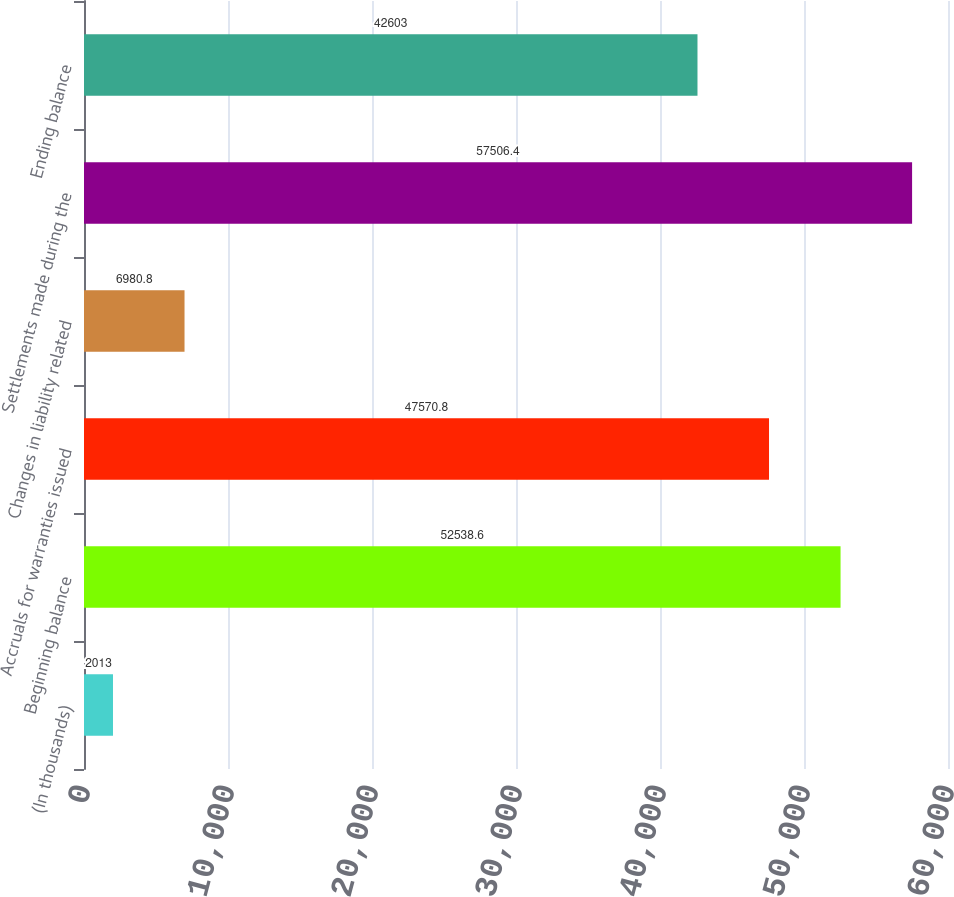<chart> <loc_0><loc_0><loc_500><loc_500><bar_chart><fcel>(In thousands)<fcel>Beginning balance<fcel>Accruals for warranties issued<fcel>Changes in liability related<fcel>Settlements made during the<fcel>Ending balance<nl><fcel>2013<fcel>52538.6<fcel>47570.8<fcel>6980.8<fcel>57506.4<fcel>42603<nl></chart> 